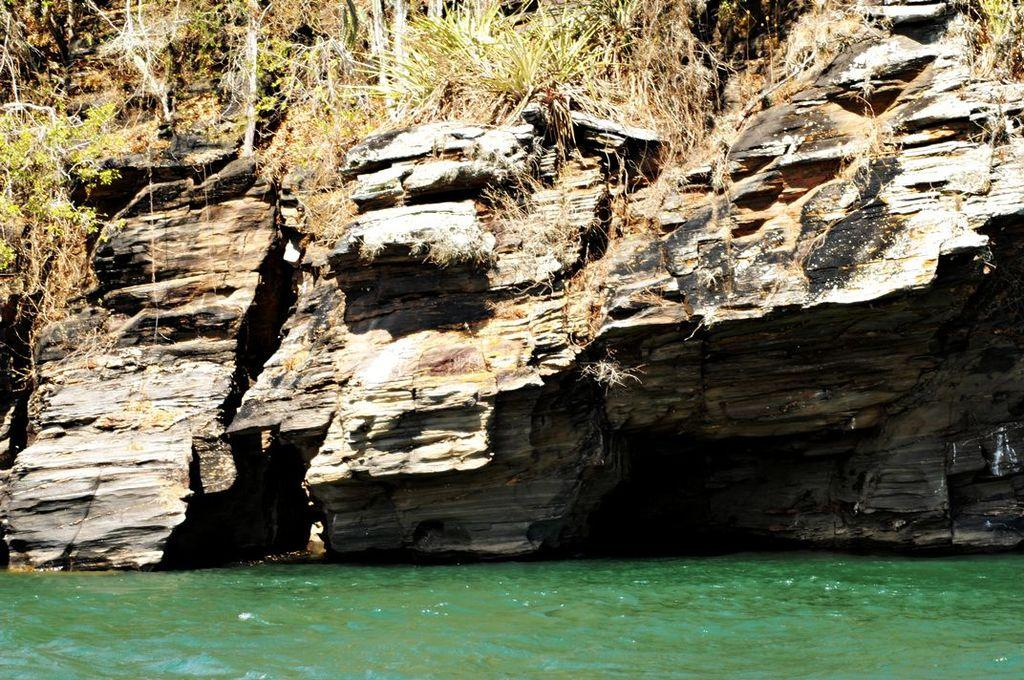What is the primary element visible in the image? There is water in the image. What type of natural elements can be seen in the image? There are plants and rocks visible in the image. What type of respect can be seen in the image? There is no indication of respect in the image, as it primarily features water, plants, and rocks. 